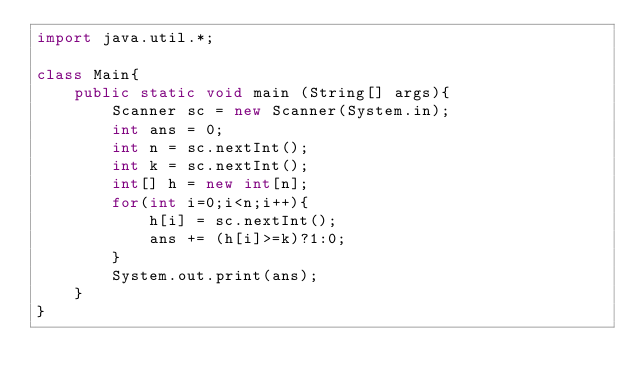Convert code to text. <code><loc_0><loc_0><loc_500><loc_500><_Java_>import java.util.*;

class Main{
    public static void main (String[] args){
        Scanner sc = new Scanner(System.in);
        int ans = 0;
        int n = sc.nextInt();
        int k = sc.nextInt();
        int[] h = new int[n];
        for(int i=0;i<n;i++){
            h[i] = sc.nextInt();
            ans += (h[i]>=k)?1:0;
        }
        System.out.print(ans);
    }
}</code> 